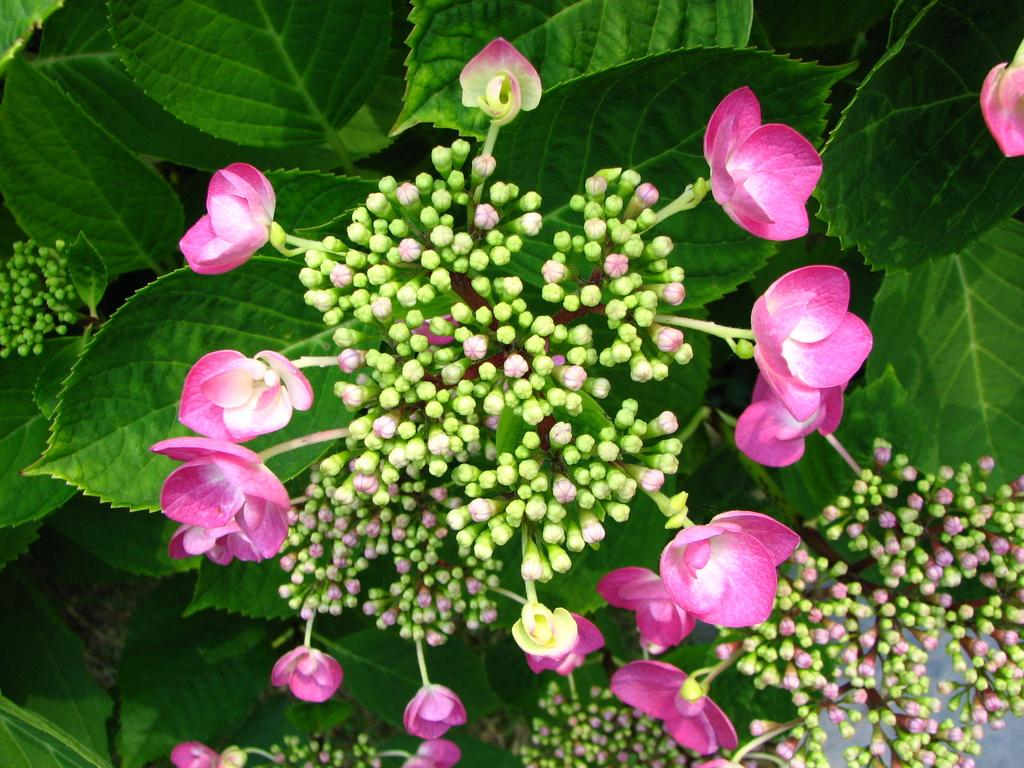What is visible in the foreground of the image? There are buds and flowers of a plant in the foreground of the image. What can be seen in the background of the image? There are leaves in the background of the image. What type of whip is being used to order the science in the image? There is no whip or science present in the image; it features a plant with buds, flowers, and leaves. 